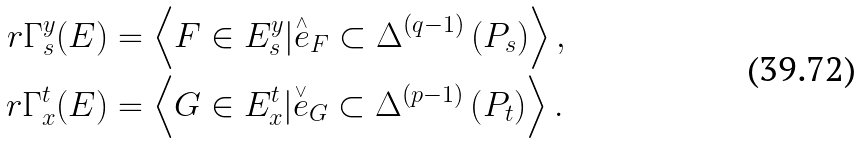Convert formula to latex. <formula><loc_0><loc_0><loc_500><loc_500>r \Gamma _ { s } ^ { y } ( { E } ) & = \left \langle F \in E _ { s } ^ { y } | \overset { _ { \wedge } } { e } _ { F } \subset { \Delta } ^ { \left ( q - 1 \right ) } \left ( P _ { s } \right ) \right \rangle , \\ r \Gamma _ { x } ^ { t } ( { E } ) & = \left \langle G \in E _ { x } ^ { t } | \overset { _ { \vee } } { e } _ { G } \subset { \Delta } ^ { \left ( p - 1 \right ) } \left ( P _ { t } \right ) \right \rangle .</formula> 